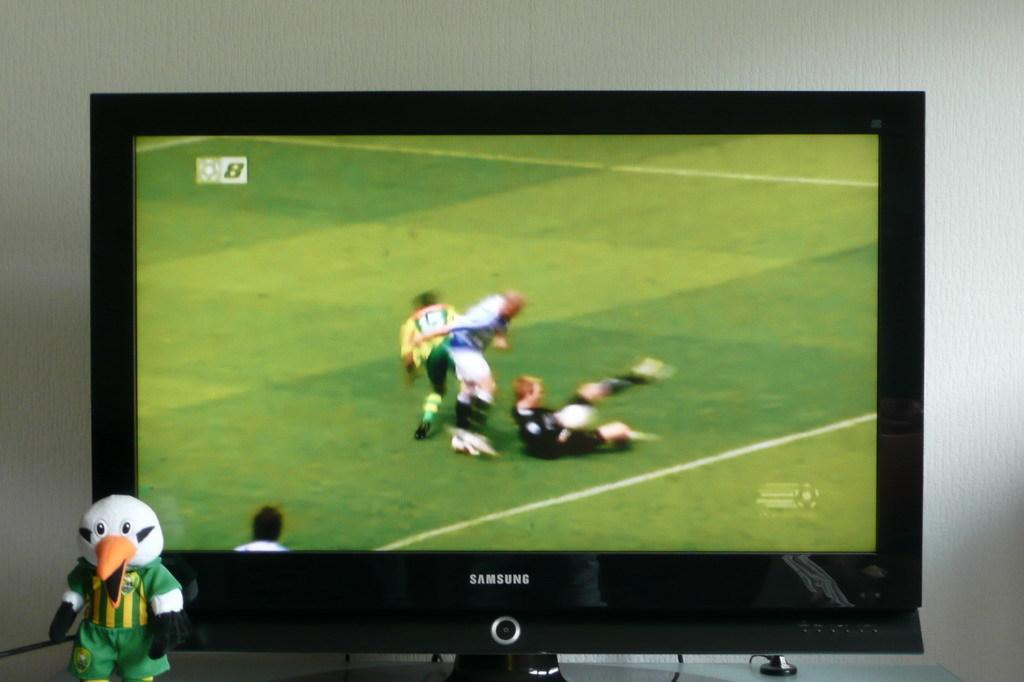<image>
Present a compact description of the photo's key features. A soccer game is displayed on a Samsung brand TV. 